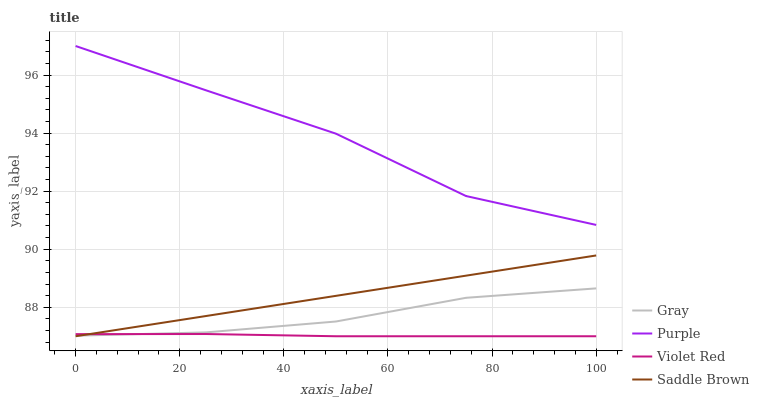Does Violet Red have the minimum area under the curve?
Answer yes or no. Yes. Does Purple have the maximum area under the curve?
Answer yes or no. Yes. Does Gray have the minimum area under the curve?
Answer yes or no. No. Does Gray have the maximum area under the curve?
Answer yes or no. No. Is Saddle Brown the smoothest?
Answer yes or no. Yes. Is Purple the roughest?
Answer yes or no. Yes. Is Gray the smoothest?
Answer yes or no. No. Is Gray the roughest?
Answer yes or no. No. Does Violet Red have the lowest value?
Answer yes or no. Yes. Does Gray have the lowest value?
Answer yes or no. No. Does Purple have the highest value?
Answer yes or no. Yes. Does Gray have the highest value?
Answer yes or no. No. Is Gray less than Purple?
Answer yes or no. Yes. Is Purple greater than Gray?
Answer yes or no. Yes. Does Violet Red intersect Saddle Brown?
Answer yes or no. Yes. Is Violet Red less than Saddle Brown?
Answer yes or no. No. Is Violet Red greater than Saddle Brown?
Answer yes or no. No. Does Gray intersect Purple?
Answer yes or no. No. 